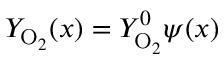<formula> <loc_0><loc_0><loc_500><loc_500>Y _ { O _ { 2 } } ( x ) = Y _ { O _ { 2 } } ^ { 0 } \psi ( x )</formula> 